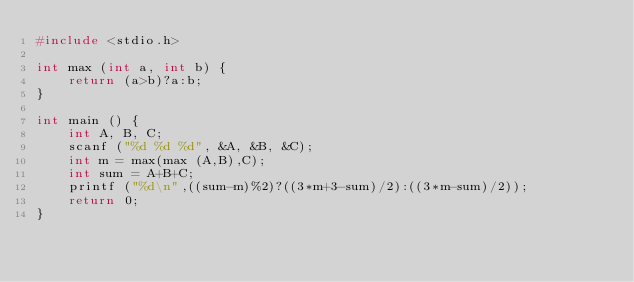Convert code to text. <code><loc_0><loc_0><loc_500><loc_500><_C_>#include <stdio.h>

int max (int a, int b) {
	return (a>b)?a:b;
}

int main () {
	int A, B, C;
	scanf ("%d %d %d", &A, &B, &C);
	int m = max(max (A,B),C);
	int sum = A+B+C;
	printf ("%d\n",((sum-m)%2)?((3*m+3-sum)/2):((3*m-sum)/2));
	return 0;
}
</code> 